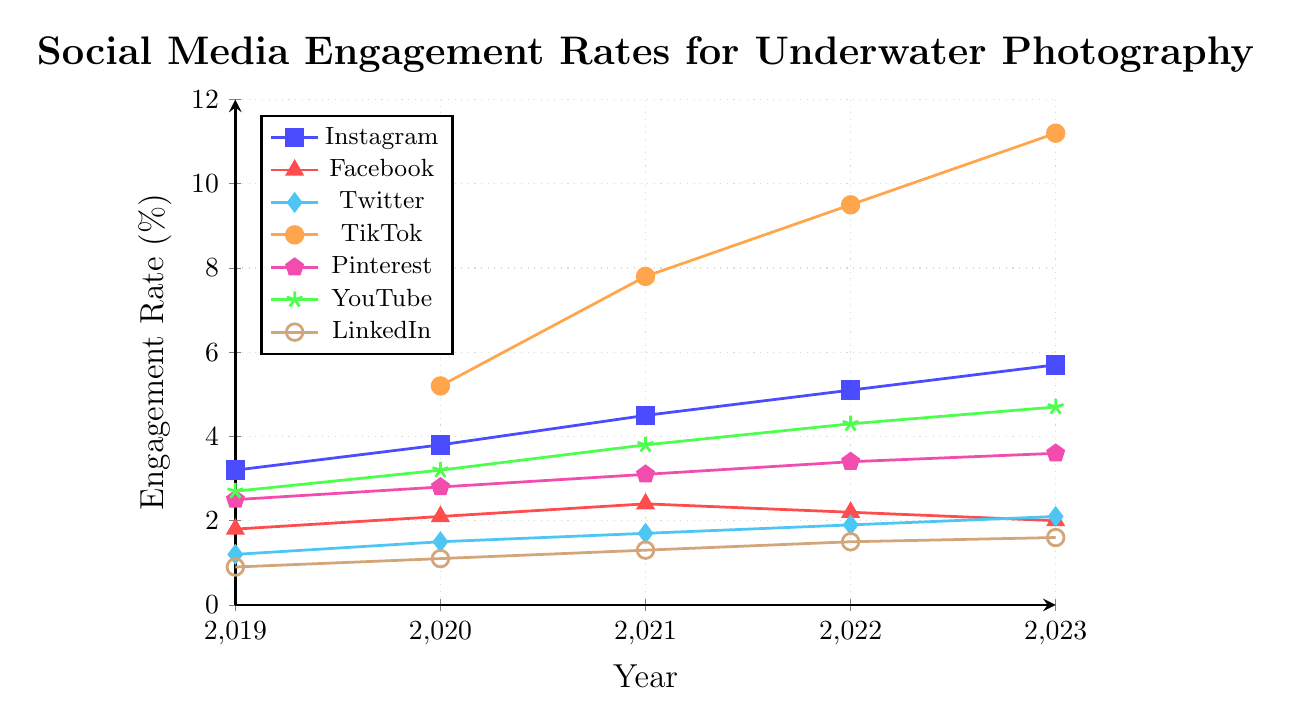Which platform had the highest engagement rate in 2023? To find the highest engagement rate for 2023, look at the endpoints of each line for 2023. TikTok has the highest endpoint at 11.2%.
Answer: TikTok Which platform saw the most significant increase in engagement rate from 2020 to 2023? To determine the platform with the most significant increase, subtract the 2020 engagement rate from the 2023 engagement rate for each platform and compare the differences. TikTok had the largest increase of 6.0% (11.2% - 5.2%).
Answer: TikTok How did YouTube's engagement rate change from 2019 to 2023? Trace YouTube's engagement rate from 2019 to 2023. It started at 2.7% in 2019 and rose to 4.7% in 2023. The change is 4.7% - 2.7% = 2.0%.
Answer: Increased by 2.0% Which platform had a decrease in engagement rate in 2022 compared to 2021? Compare the engagement rates between 2021 and 2022 for each platform. Facebook's engagement rate decreased from 2.4% in 2021 to 2.2% in 2022.
Answer: Facebook What is the average engagement rate for Instagram across the years provided? Add the engagement rates for Instagram from 2019 to 2023 and divide by the number of years: (3.2 + 3.8 + 4.5 + 5.1 + 5.7)/5 = 22.3/5 = 4.46%.
Answer: 4.46% Which two platforms had the closest engagement rates in 2021? Compare the engagement rates for 2021: Instagram 4.5%, Facebook 2.4%, Twitter 1.7%, TikTok 7.8%, Pinterest 3.1%, YouTube 3.8%, LinkedIn 1.3%. Pinterest (3.1%) and YouTube (3.8%) had the closest rates. The difference is 0.7%.
Answer: Pinterest and YouTube What color represents Twitter on the graph? Identify the color associated with Twitter by looking at the legend. Twitter is represented by the cyan color.
Answer: Cyan For which year did TikTok start to have engagement rate data? Check the plot to see when TikTok's line starts appearing. It starts in 2020.
Answer: 2020 What is the trend for Facebook's engagement rate from 2019 to 2023? Trace the line for Facebook from 2019 to 2023. The engagement rate increased initially (2019-2021) and then decreased (2021-2023), showing an overall downward trend towards the end.
Answer: Decreasing after an initial rise Which platform has the lowest engagement rate in 2023? Compare the engagement rates for each platform in 2023. LinkedIn has the lowest engagement rate at 1.6%.
Answer: LinkedIn 